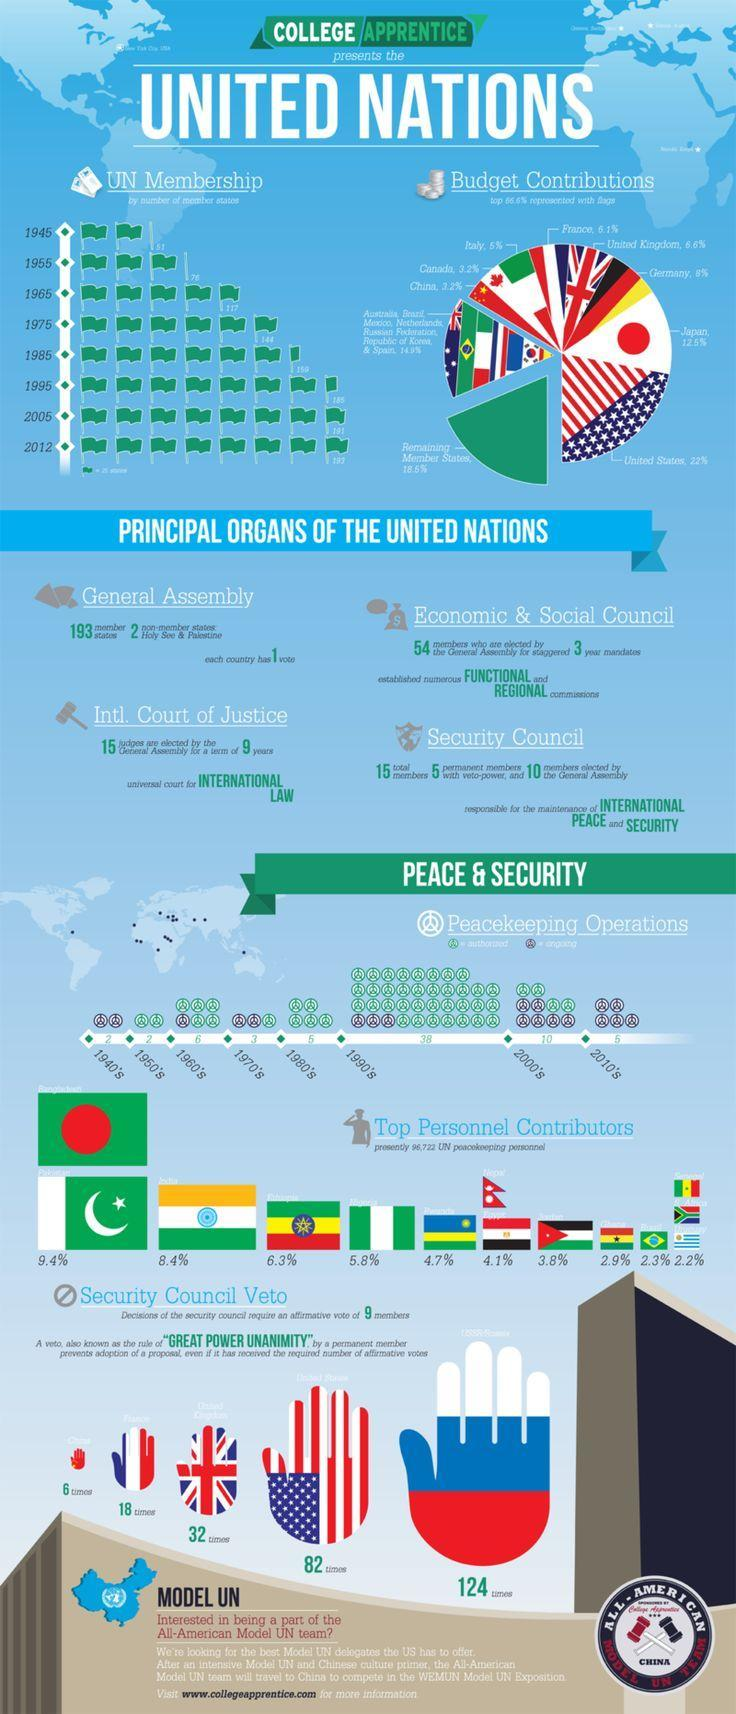How many member states were there in the UN in 2005?
Answer the question with a short phrase. 191 What percentage is contributed by Italy in the UN peacekeeping operations budget? 5% How many member states were there in the UN in 2012? 193 How many members in the security council are elected by the General assembly? 10 What percentage is contributed by Canada in the UN peacekeeping operations budget? 3.2% How many countries were there in the UN in 1945? 51 When was the United Nations founded? 1945 What percentage of the UN peacekeeping personnels were contributed by pakistan? 9.4% What is the total number of members in the security council of the United Nations? 15 What percentage of the UN peacekeeping personnels were contributed by Ethiopia? 6.3% 